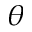<formula> <loc_0><loc_0><loc_500><loc_500>\theta</formula> 